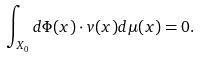Convert formula to latex. <formula><loc_0><loc_0><loc_500><loc_500>\int _ { X _ { 0 } } d \Phi ( x ) \cdot v ( x ) d \mu ( x ) = 0 .</formula> 